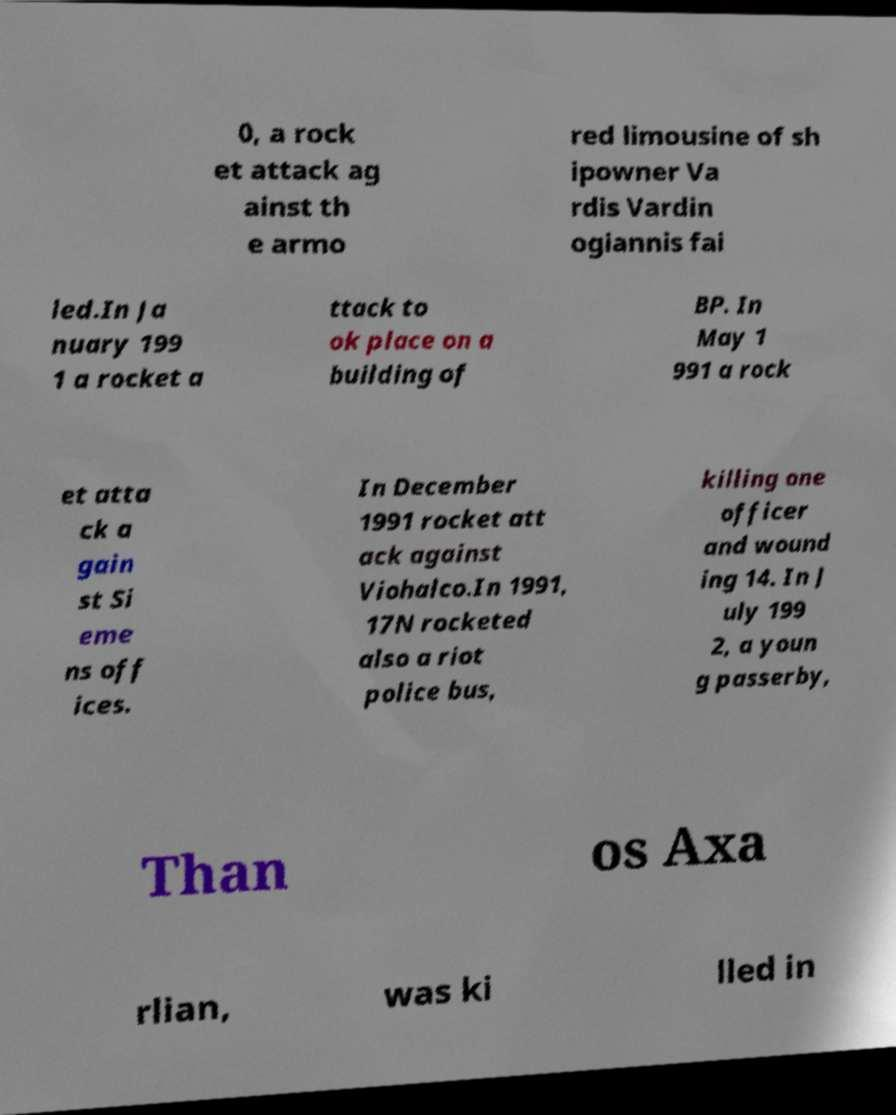What messages or text are displayed in this image? I need them in a readable, typed format. 0, a rock et attack ag ainst th e armo red limousine of sh ipowner Va rdis Vardin ogiannis fai led.In Ja nuary 199 1 a rocket a ttack to ok place on a building of BP. In May 1 991 a rock et atta ck a gain st Si eme ns off ices. In December 1991 rocket att ack against Viohalco.In 1991, 17N rocketed also a riot police bus, killing one officer and wound ing 14. In J uly 199 2, a youn g passerby, Than os Axa rlian, was ki lled in 